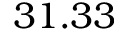<formula> <loc_0><loc_0><loc_500><loc_500>3 1 . 3 3</formula> 